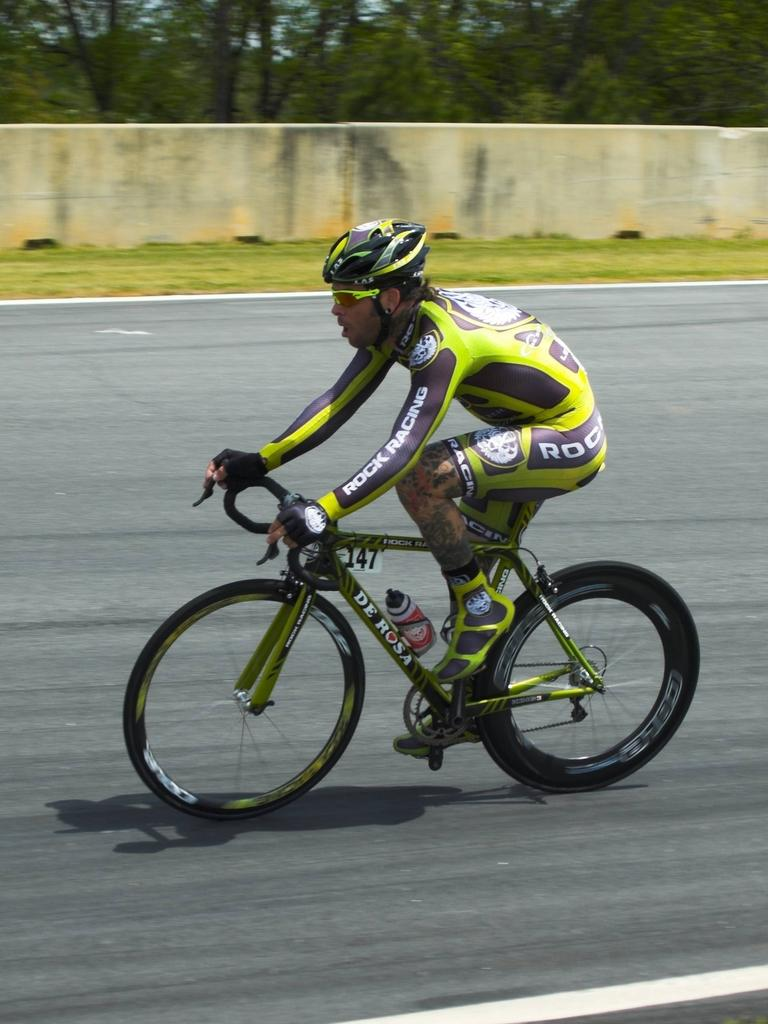What is the person in the image doing? The person is riding a cycle in the image. Where is the person riding the cycle? The person is on the road. What safety precaution is the person taking while riding the cycle? The person is wearing a helmet. What can be seen in the background of the image? There are trees, grass, and a wall in the background of the image. What type of pies can be seen baking on the sand in the image? There is no sand or pies present in the image; it features a person riding a cycle on the road. 